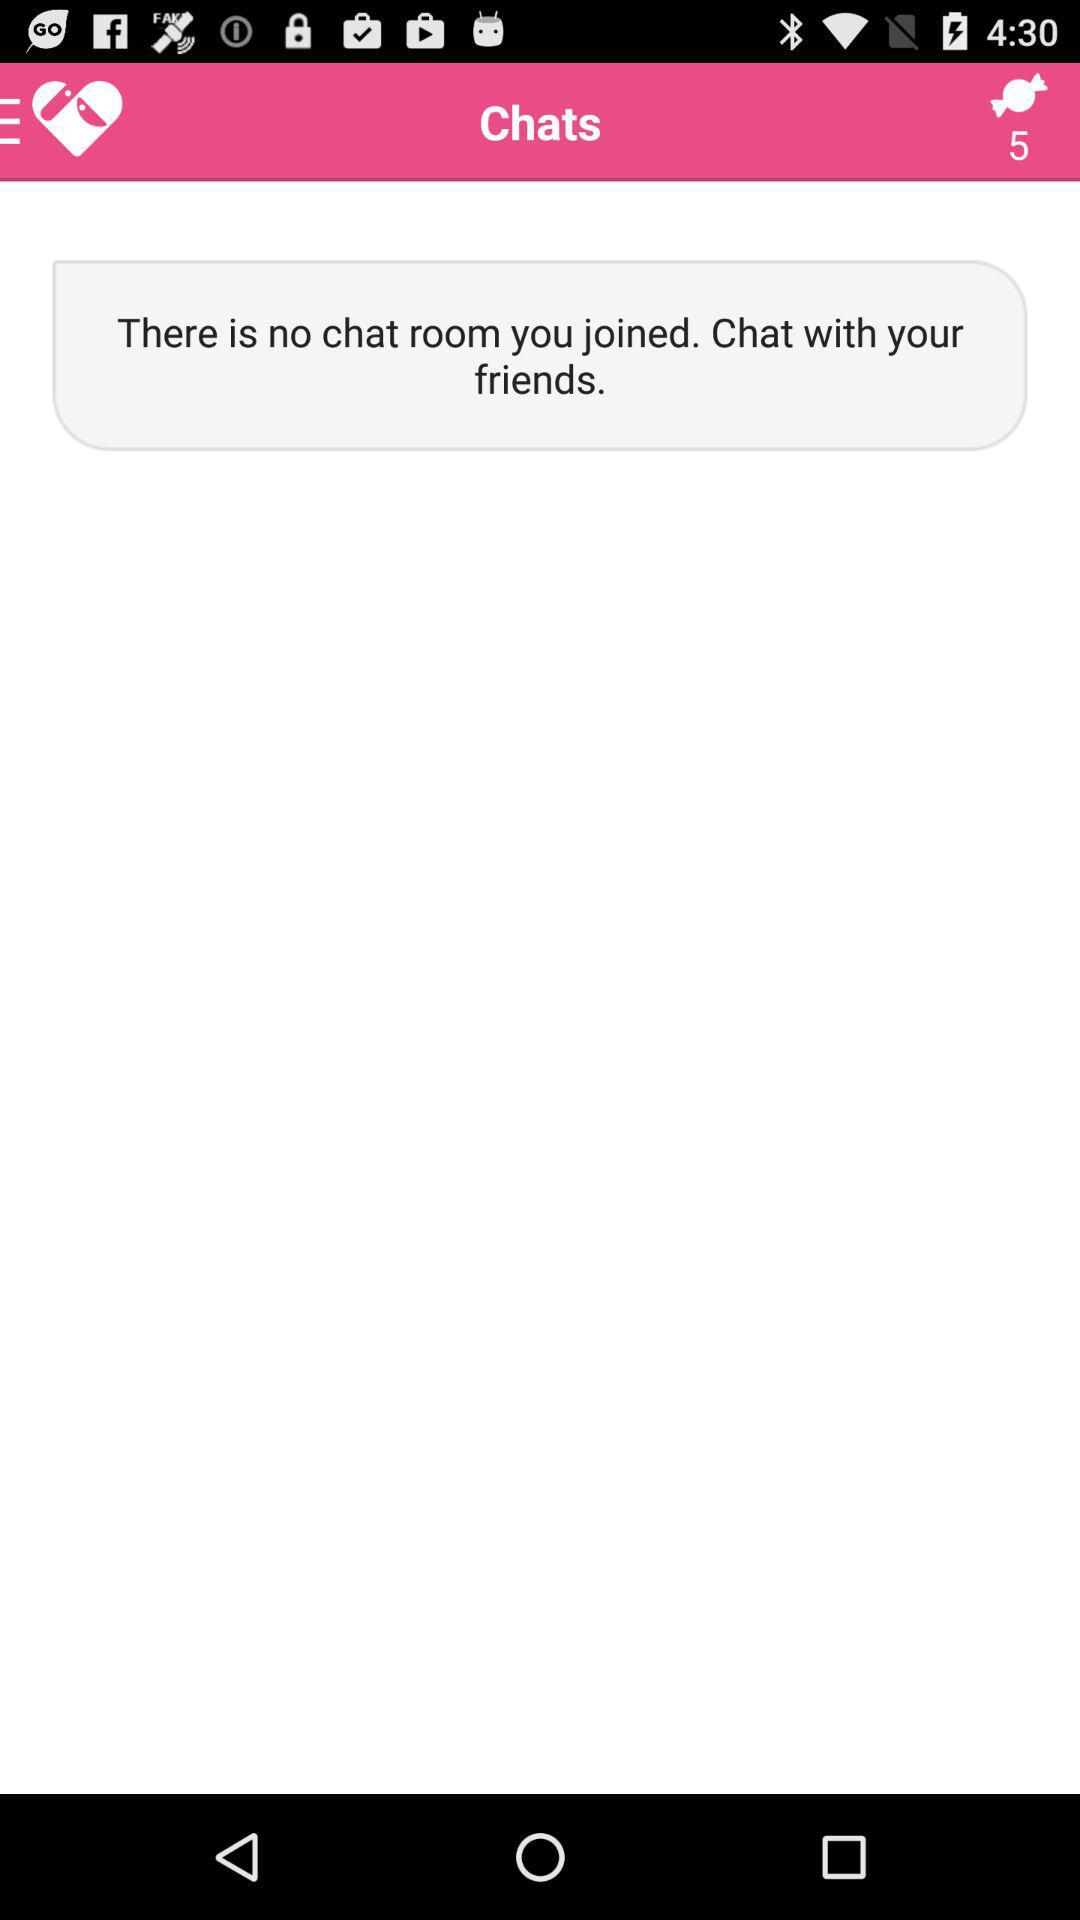Is there any chat room that the user has joined? There is no chat room that the user has joined. 